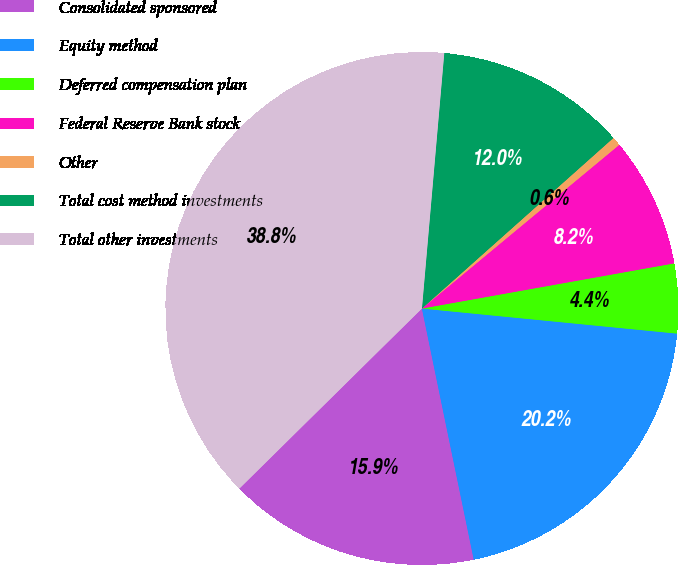Convert chart. <chart><loc_0><loc_0><loc_500><loc_500><pie_chart><fcel>Consolidated sponsored<fcel>Equity method<fcel>Deferred compensation plan<fcel>Federal Reserve Bank stock<fcel>Other<fcel>Total cost method investments<fcel>Total other investments<nl><fcel>15.85%<fcel>20.2%<fcel>4.38%<fcel>8.2%<fcel>0.56%<fcel>12.03%<fcel>38.78%<nl></chart> 